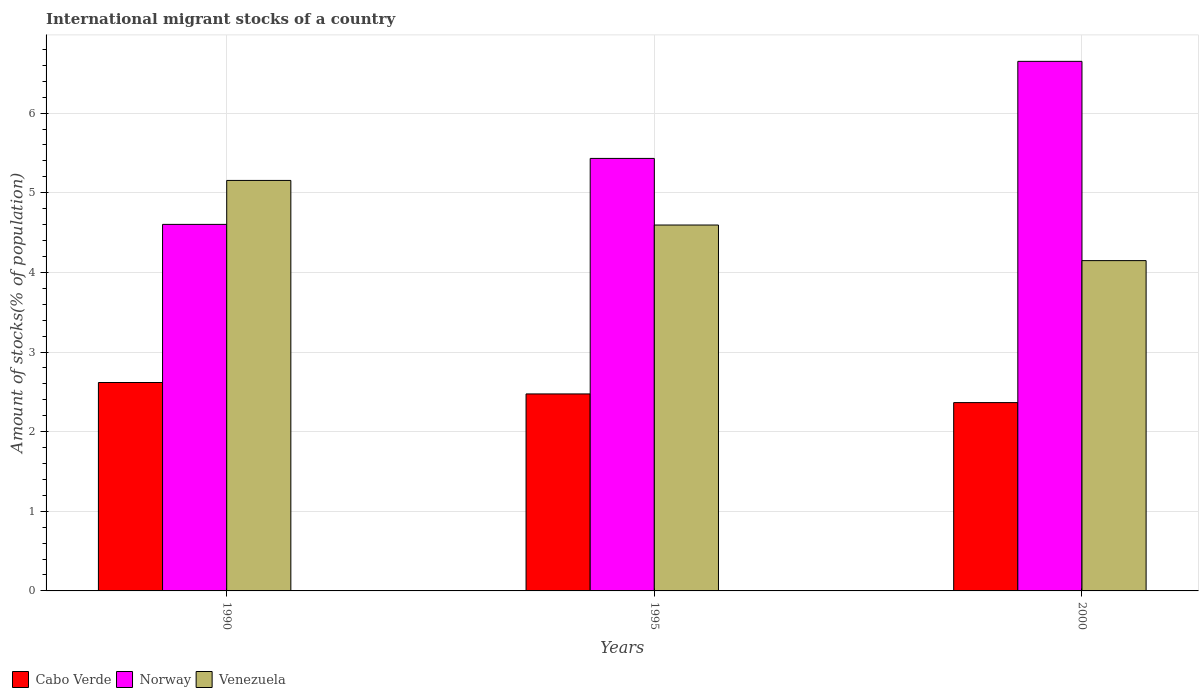How many different coloured bars are there?
Provide a short and direct response. 3. How many groups of bars are there?
Your answer should be compact. 3. Are the number of bars per tick equal to the number of legend labels?
Provide a short and direct response. Yes. What is the label of the 1st group of bars from the left?
Your answer should be very brief. 1990. In how many cases, is the number of bars for a given year not equal to the number of legend labels?
Make the answer very short. 0. What is the amount of stocks in in Norway in 1995?
Offer a very short reply. 5.43. Across all years, what is the maximum amount of stocks in in Cabo Verde?
Your answer should be very brief. 2.62. Across all years, what is the minimum amount of stocks in in Venezuela?
Offer a terse response. 4.15. In which year was the amount of stocks in in Cabo Verde maximum?
Your answer should be very brief. 1990. What is the total amount of stocks in in Norway in the graph?
Make the answer very short. 16.68. What is the difference between the amount of stocks in in Venezuela in 1990 and that in 2000?
Your answer should be compact. 1.01. What is the difference between the amount of stocks in in Cabo Verde in 1995 and the amount of stocks in in Venezuela in 1990?
Keep it short and to the point. -2.68. What is the average amount of stocks in in Cabo Verde per year?
Give a very brief answer. 2.49. In the year 2000, what is the difference between the amount of stocks in in Cabo Verde and amount of stocks in in Venezuela?
Your answer should be compact. -1.78. In how many years, is the amount of stocks in in Venezuela greater than 6.2 %?
Provide a succinct answer. 0. What is the ratio of the amount of stocks in in Norway in 1990 to that in 2000?
Your response must be concise. 0.69. Is the difference between the amount of stocks in in Cabo Verde in 1990 and 2000 greater than the difference between the amount of stocks in in Venezuela in 1990 and 2000?
Your response must be concise. No. What is the difference between the highest and the second highest amount of stocks in in Venezuela?
Your response must be concise. 0.56. What is the difference between the highest and the lowest amount of stocks in in Venezuela?
Your answer should be compact. 1.01. Is the sum of the amount of stocks in in Norway in 1990 and 2000 greater than the maximum amount of stocks in in Cabo Verde across all years?
Offer a very short reply. Yes. What does the 1st bar from the left in 1995 represents?
Your response must be concise. Cabo Verde. What does the 1st bar from the right in 1990 represents?
Give a very brief answer. Venezuela. Is it the case that in every year, the sum of the amount of stocks in in Venezuela and amount of stocks in in Cabo Verde is greater than the amount of stocks in in Norway?
Make the answer very short. No. What is the difference between two consecutive major ticks on the Y-axis?
Offer a terse response. 1. Are the values on the major ticks of Y-axis written in scientific E-notation?
Offer a terse response. No. Where does the legend appear in the graph?
Make the answer very short. Bottom left. How are the legend labels stacked?
Offer a very short reply. Horizontal. What is the title of the graph?
Offer a terse response. International migrant stocks of a country. What is the label or title of the X-axis?
Ensure brevity in your answer.  Years. What is the label or title of the Y-axis?
Give a very brief answer. Amount of stocks(% of population). What is the Amount of stocks(% of population) in Cabo Verde in 1990?
Offer a very short reply. 2.62. What is the Amount of stocks(% of population) of Norway in 1990?
Offer a very short reply. 4.6. What is the Amount of stocks(% of population) in Venezuela in 1990?
Offer a terse response. 5.15. What is the Amount of stocks(% of population) in Cabo Verde in 1995?
Your answer should be very brief. 2.47. What is the Amount of stocks(% of population) in Norway in 1995?
Make the answer very short. 5.43. What is the Amount of stocks(% of population) in Venezuela in 1995?
Offer a very short reply. 4.59. What is the Amount of stocks(% of population) of Cabo Verde in 2000?
Ensure brevity in your answer.  2.36. What is the Amount of stocks(% of population) of Norway in 2000?
Provide a short and direct response. 6.65. What is the Amount of stocks(% of population) of Venezuela in 2000?
Keep it short and to the point. 4.15. Across all years, what is the maximum Amount of stocks(% of population) in Cabo Verde?
Your response must be concise. 2.62. Across all years, what is the maximum Amount of stocks(% of population) of Norway?
Ensure brevity in your answer.  6.65. Across all years, what is the maximum Amount of stocks(% of population) in Venezuela?
Provide a succinct answer. 5.15. Across all years, what is the minimum Amount of stocks(% of population) of Cabo Verde?
Provide a short and direct response. 2.36. Across all years, what is the minimum Amount of stocks(% of population) of Norway?
Provide a succinct answer. 4.6. Across all years, what is the minimum Amount of stocks(% of population) in Venezuela?
Make the answer very short. 4.15. What is the total Amount of stocks(% of population) in Cabo Verde in the graph?
Provide a succinct answer. 7.46. What is the total Amount of stocks(% of population) of Norway in the graph?
Your answer should be compact. 16.68. What is the total Amount of stocks(% of population) in Venezuela in the graph?
Ensure brevity in your answer.  13.9. What is the difference between the Amount of stocks(% of population) in Cabo Verde in 1990 and that in 1995?
Ensure brevity in your answer.  0.14. What is the difference between the Amount of stocks(% of population) in Norway in 1990 and that in 1995?
Keep it short and to the point. -0.83. What is the difference between the Amount of stocks(% of population) of Venezuela in 1990 and that in 1995?
Provide a short and direct response. 0.56. What is the difference between the Amount of stocks(% of population) of Cabo Verde in 1990 and that in 2000?
Offer a terse response. 0.25. What is the difference between the Amount of stocks(% of population) of Norway in 1990 and that in 2000?
Provide a succinct answer. -2.05. What is the difference between the Amount of stocks(% of population) in Venezuela in 1990 and that in 2000?
Your answer should be compact. 1.01. What is the difference between the Amount of stocks(% of population) of Cabo Verde in 1995 and that in 2000?
Provide a short and direct response. 0.11. What is the difference between the Amount of stocks(% of population) of Norway in 1995 and that in 2000?
Your answer should be compact. -1.22. What is the difference between the Amount of stocks(% of population) of Venezuela in 1995 and that in 2000?
Your answer should be compact. 0.45. What is the difference between the Amount of stocks(% of population) in Cabo Verde in 1990 and the Amount of stocks(% of population) in Norway in 1995?
Make the answer very short. -2.81. What is the difference between the Amount of stocks(% of population) in Cabo Verde in 1990 and the Amount of stocks(% of population) in Venezuela in 1995?
Make the answer very short. -1.98. What is the difference between the Amount of stocks(% of population) of Norway in 1990 and the Amount of stocks(% of population) of Venezuela in 1995?
Provide a short and direct response. 0.01. What is the difference between the Amount of stocks(% of population) in Cabo Verde in 1990 and the Amount of stocks(% of population) in Norway in 2000?
Provide a succinct answer. -4.03. What is the difference between the Amount of stocks(% of population) in Cabo Verde in 1990 and the Amount of stocks(% of population) in Venezuela in 2000?
Provide a succinct answer. -1.53. What is the difference between the Amount of stocks(% of population) in Norway in 1990 and the Amount of stocks(% of population) in Venezuela in 2000?
Give a very brief answer. 0.45. What is the difference between the Amount of stocks(% of population) in Cabo Verde in 1995 and the Amount of stocks(% of population) in Norway in 2000?
Your response must be concise. -4.18. What is the difference between the Amount of stocks(% of population) in Cabo Verde in 1995 and the Amount of stocks(% of population) in Venezuela in 2000?
Your answer should be very brief. -1.67. What is the difference between the Amount of stocks(% of population) of Norway in 1995 and the Amount of stocks(% of population) of Venezuela in 2000?
Make the answer very short. 1.28. What is the average Amount of stocks(% of population) in Cabo Verde per year?
Provide a short and direct response. 2.49. What is the average Amount of stocks(% of population) in Norway per year?
Your answer should be compact. 5.56. What is the average Amount of stocks(% of population) in Venezuela per year?
Your answer should be compact. 4.63. In the year 1990, what is the difference between the Amount of stocks(% of population) of Cabo Verde and Amount of stocks(% of population) of Norway?
Give a very brief answer. -1.99. In the year 1990, what is the difference between the Amount of stocks(% of population) of Cabo Verde and Amount of stocks(% of population) of Venezuela?
Your response must be concise. -2.54. In the year 1990, what is the difference between the Amount of stocks(% of population) in Norway and Amount of stocks(% of population) in Venezuela?
Ensure brevity in your answer.  -0.55. In the year 1995, what is the difference between the Amount of stocks(% of population) in Cabo Verde and Amount of stocks(% of population) in Norway?
Keep it short and to the point. -2.96. In the year 1995, what is the difference between the Amount of stocks(% of population) of Cabo Verde and Amount of stocks(% of population) of Venezuela?
Your answer should be compact. -2.12. In the year 1995, what is the difference between the Amount of stocks(% of population) of Norway and Amount of stocks(% of population) of Venezuela?
Your answer should be compact. 0.84. In the year 2000, what is the difference between the Amount of stocks(% of population) in Cabo Verde and Amount of stocks(% of population) in Norway?
Provide a short and direct response. -4.29. In the year 2000, what is the difference between the Amount of stocks(% of population) of Cabo Verde and Amount of stocks(% of population) of Venezuela?
Make the answer very short. -1.78. In the year 2000, what is the difference between the Amount of stocks(% of population) in Norway and Amount of stocks(% of population) in Venezuela?
Keep it short and to the point. 2.5. What is the ratio of the Amount of stocks(% of population) in Cabo Verde in 1990 to that in 1995?
Give a very brief answer. 1.06. What is the ratio of the Amount of stocks(% of population) in Norway in 1990 to that in 1995?
Give a very brief answer. 0.85. What is the ratio of the Amount of stocks(% of population) of Venezuela in 1990 to that in 1995?
Offer a very short reply. 1.12. What is the ratio of the Amount of stocks(% of population) of Cabo Verde in 1990 to that in 2000?
Make the answer very short. 1.11. What is the ratio of the Amount of stocks(% of population) in Norway in 1990 to that in 2000?
Ensure brevity in your answer.  0.69. What is the ratio of the Amount of stocks(% of population) in Venezuela in 1990 to that in 2000?
Give a very brief answer. 1.24. What is the ratio of the Amount of stocks(% of population) in Cabo Verde in 1995 to that in 2000?
Your answer should be compact. 1.05. What is the ratio of the Amount of stocks(% of population) in Norway in 1995 to that in 2000?
Your response must be concise. 0.82. What is the ratio of the Amount of stocks(% of population) in Venezuela in 1995 to that in 2000?
Make the answer very short. 1.11. What is the difference between the highest and the second highest Amount of stocks(% of population) of Cabo Verde?
Offer a very short reply. 0.14. What is the difference between the highest and the second highest Amount of stocks(% of population) of Norway?
Provide a short and direct response. 1.22. What is the difference between the highest and the second highest Amount of stocks(% of population) in Venezuela?
Your response must be concise. 0.56. What is the difference between the highest and the lowest Amount of stocks(% of population) of Cabo Verde?
Give a very brief answer. 0.25. What is the difference between the highest and the lowest Amount of stocks(% of population) of Norway?
Provide a short and direct response. 2.05. 